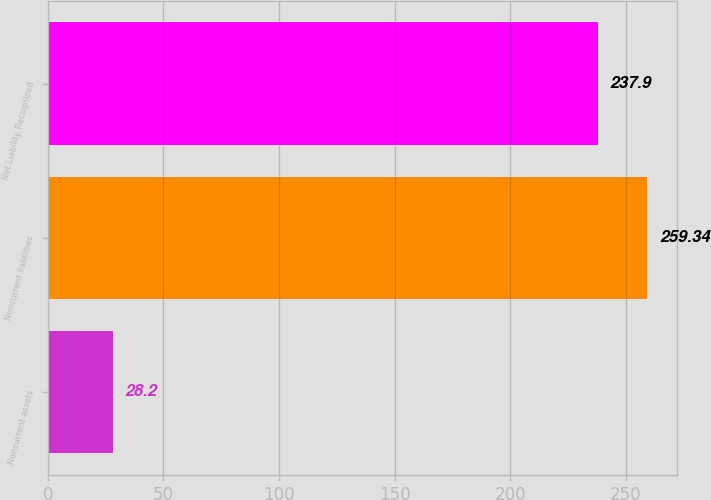Convert chart to OTSL. <chart><loc_0><loc_0><loc_500><loc_500><bar_chart><fcel>Noncurrent assets<fcel>Noncurrent liabilities<fcel>Net Liability Recognized<nl><fcel>28.2<fcel>259.34<fcel>237.9<nl></chart> 